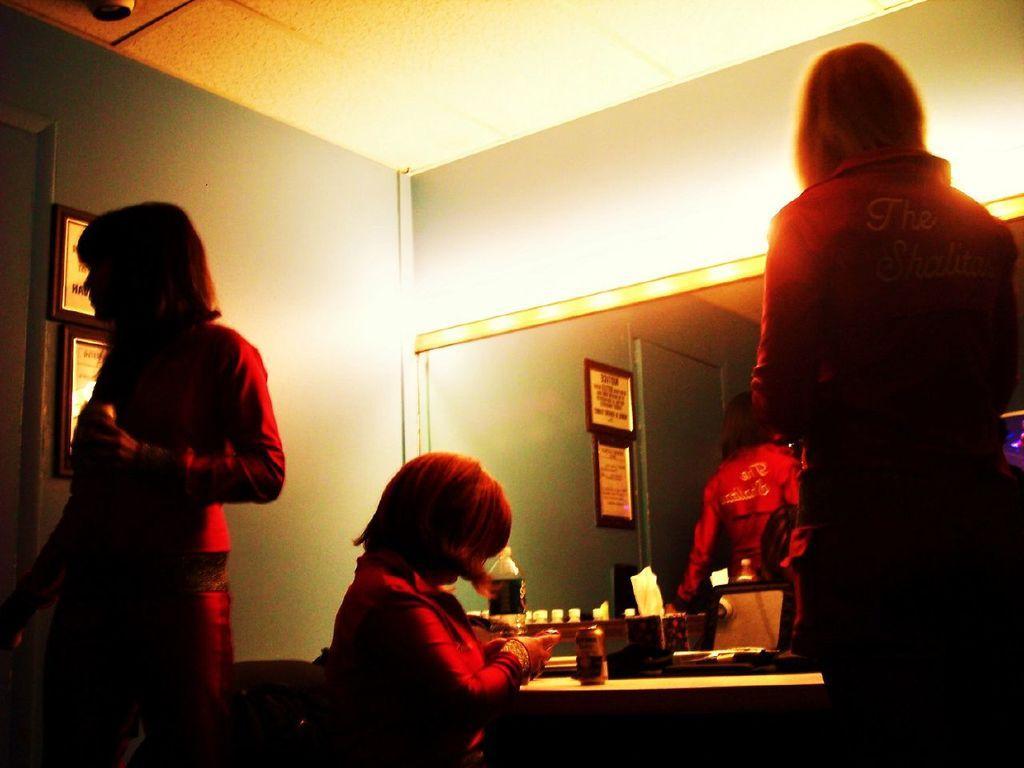In one or two sentences, can you explain what this image depicts? In the center of the image we can see a person sitting. At the bottom there is a table and we can see tins, bottle and some objects placed on the table. There are people standing. In the background there is a mirror and a wall. We can see frames placed on the wall. 